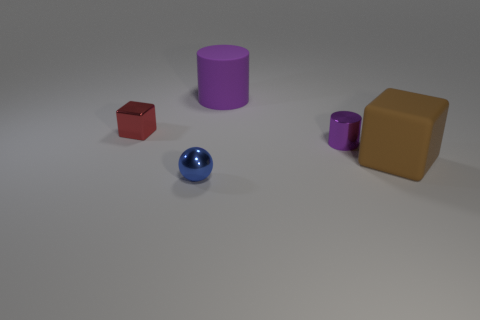Can you describe the colors of the objects presented in the image? Certainly, we see a variety of colors: the object in the foreground is a shiny blue sphere, there's a red cube to its left, a large purple cylinder in the middle, a small purple cup to the right, and a brown cube towards the back. Which object seems to be in the foreground and which one is in the background? The shiny blue sphere is in the foreground, closest to our viewpoint. The large brown cube appears to be in the background, furthest from our viewpoint. 